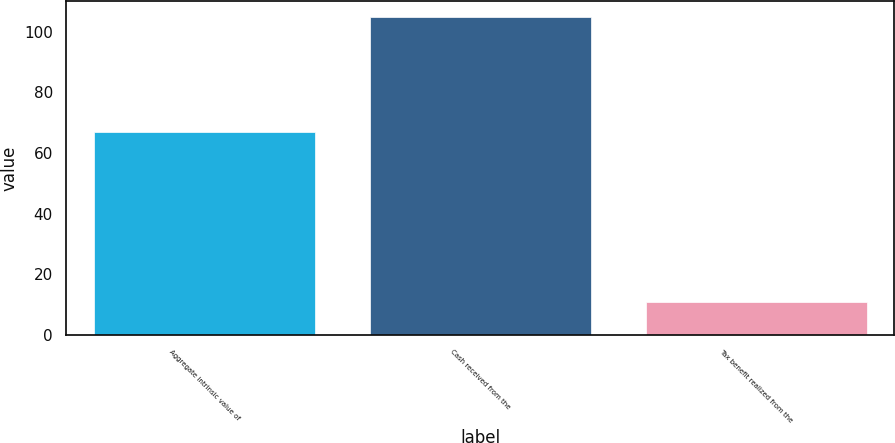<chart> <loc_0><loc_0><loc_500><loc_500><bar_chart><fcel>Aggregate intrinsic value of<fcel>Cash received from the<fcel>Tax benefit realized from the<nl><fcel>67<fcel>105<fcel>11<nl></chart> 